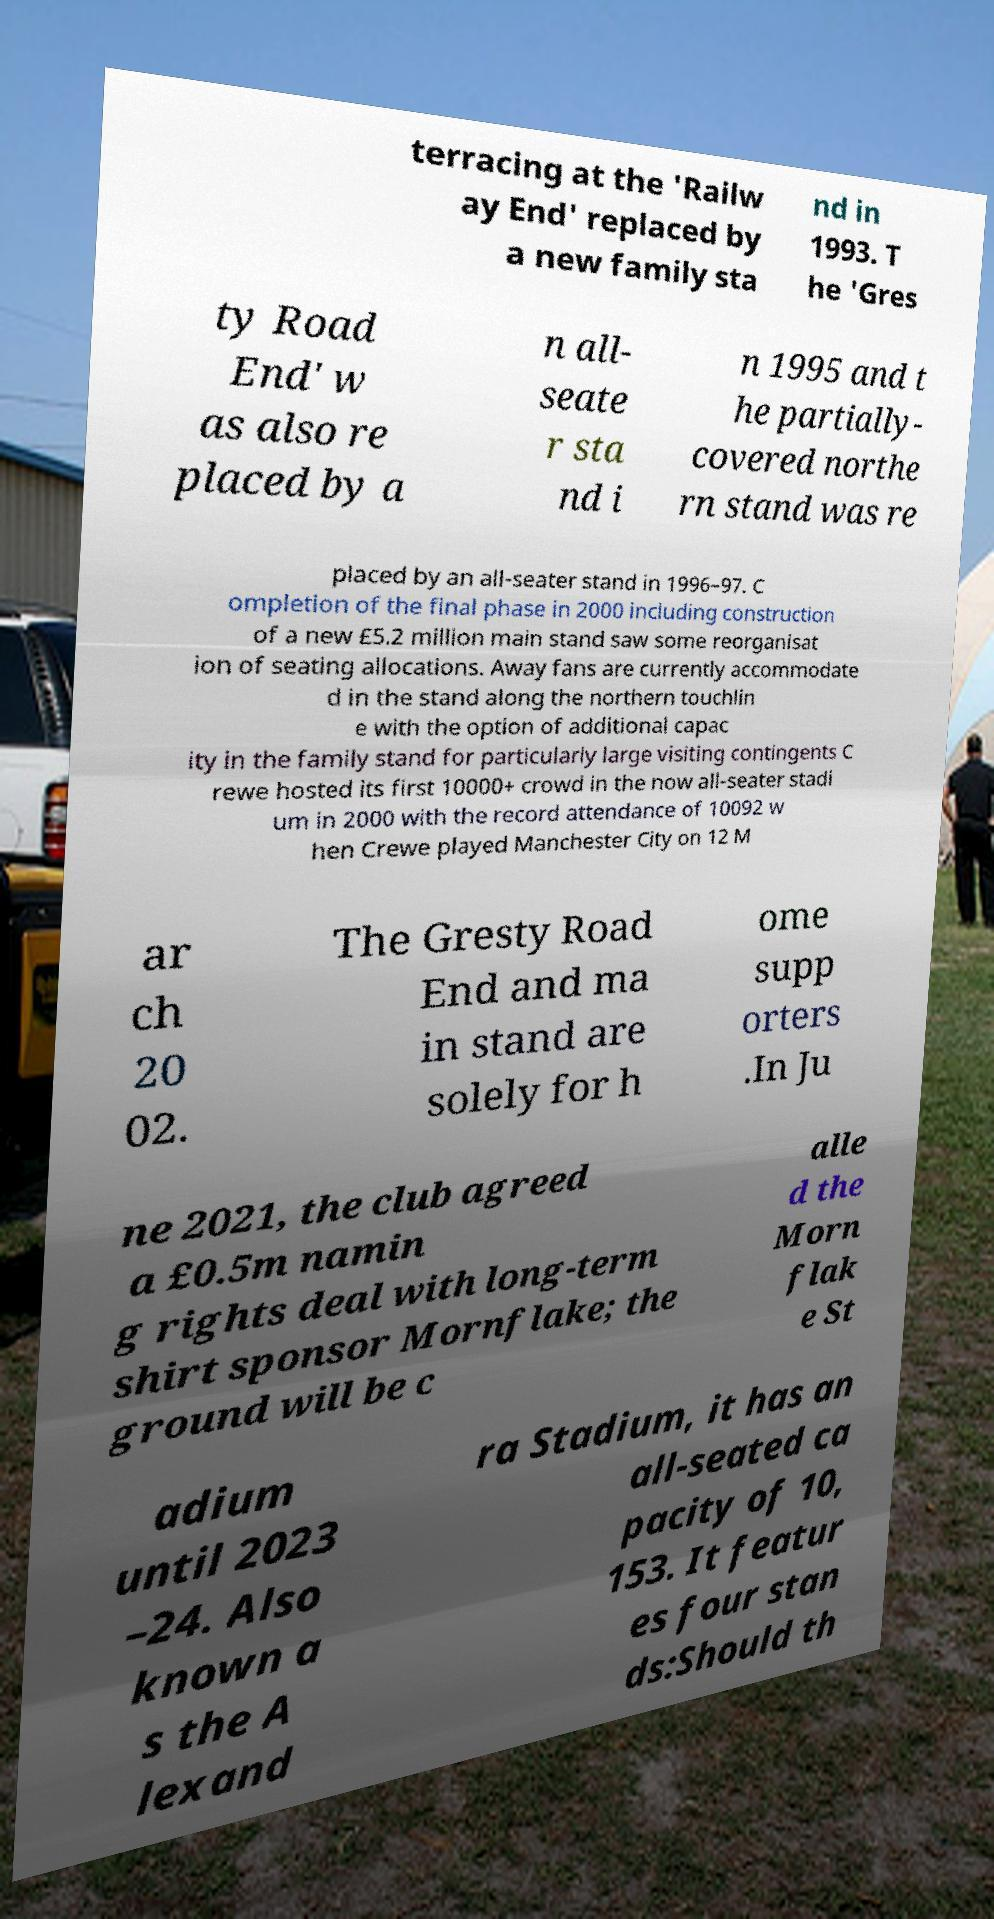Please read and relay the text visible in this image. What does it say? terracing at the 'Railw ay End' replaced by a new family sta nd in 1993. T he 'Gres ty Road End' w as also re placed by a n all- seate r sta nd i n 1995 and t he partially- covered northe rn stand was re placed by an all-seater stand in 1996–97. C ompletion of the final phase in 2000 including construction of a new £5.2 million main stand saw some reorganisat ion of seating allocations. Away fans are currently accommodate d in the stand along the northern touchlin e with the option of additional capac ity in the family stand for particularly large visiting contingents C rewe hosted its first 10000+ crowd in the now all-seater stadi um in 2000 with the record attendance of 10092 w hen Crewe played Manchester City on 12 M ar ch 20 02. The Gresty Road End and ma in stand are solely for h ome supp orters .In Ju ne 2021, the club agreed a £0.5m namin g rights deal with long-term shirt sponsor Mornflake; the ground will be c alle d the Morn flak e St adium until 2023 –24. Also known a s the A lexand ra Stadium, it has an all-seated ca pacity of 10, 153. It featur es four stan ds:Should th 